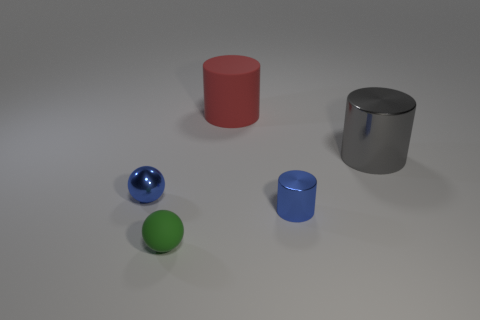Could you infer the lighting setup in the scene based on the shadows and reflections? From the shadows and reflections in the image, it appears there is a single diffuse light source from above casting soft shadows directly beneath the objects. This kind of lighting results in a more generalized illumination with fewer harsh shadows, which can be seen in the gentle gradation of shadow tones on the ground and the diffused reflections on the surfaces of the shapes. Does the lighting affect the perception of the colors and textures of the objects? Absolutely. The soft, diffuse lighting ensures that the colors and textures of the objects are perceived without strong contrast. The metallic or reflective surfaces appear more vibrant and have discernible highlights, while the matte surfaces seem flat and uniform due to their diffuse reflection of light. The light enhances the visibility of the unique material characteristics of each object. 